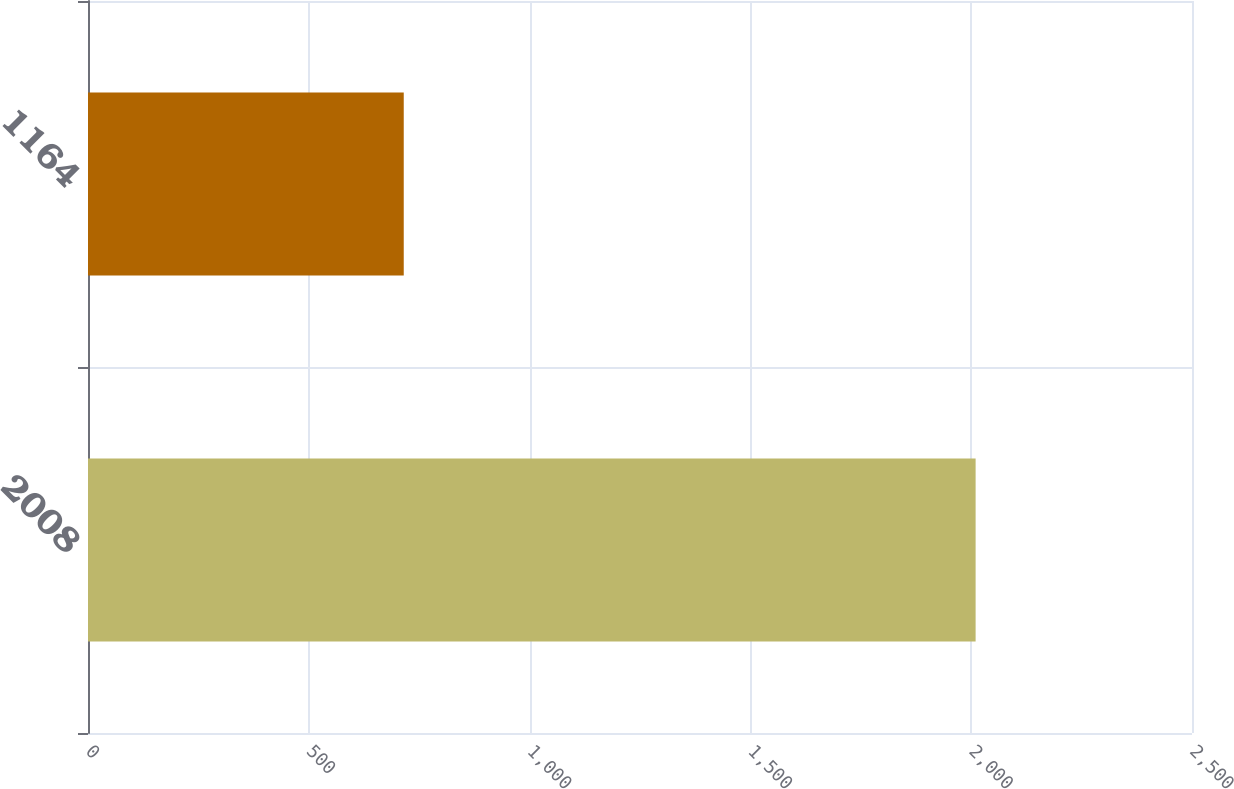<chart> <loc_0><loc_0><loc_500><loc_500><bar_chart><fcel>2008<fcel>1164<nl><fcel>2010<fcel>715<nl></chart> 